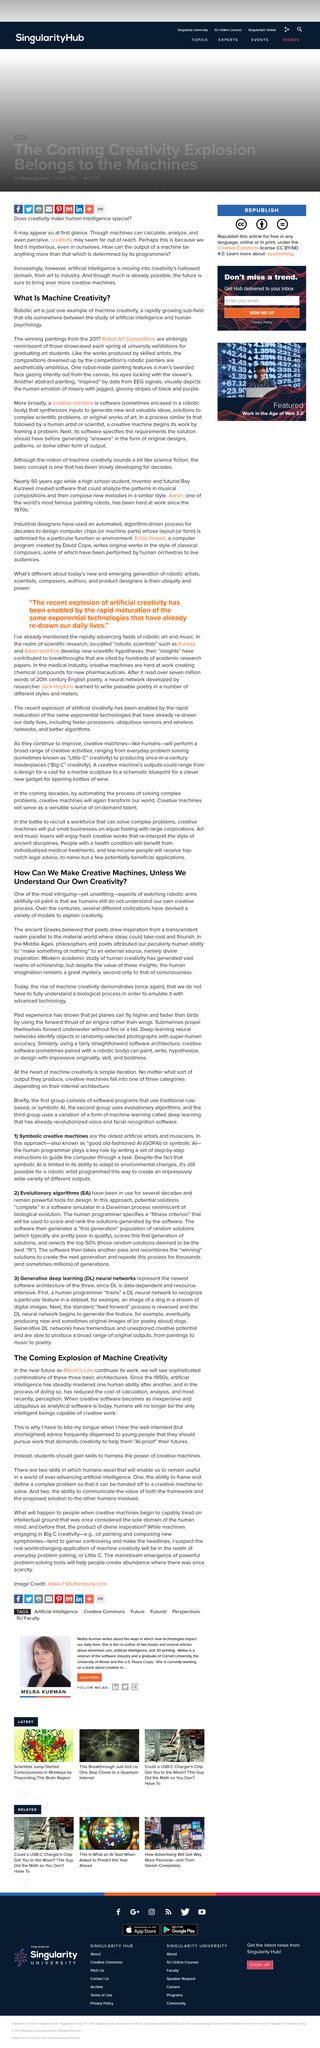Specify some key components in this picture. Philosophers and poets in the Middle Ages attributed the human ability to "make something of nothing" to an external source, which was considered a divine gift. It is necessary for humans to no longer be the only intelligent beings capable of creative work when creative software becomes as inexpensive and ubiquitous as analytical software is today. The study of artificial intelligence and human psychology is what defines machine creativity, which involves the creation of innovative ideas and solutions through the use of advanced algorithms, data analysis, and machine learning techniques. According to the article, machines, in addition to humans, will be capable of creativity and creative work. Machine creativity refers to the use of technology to generate creative works or ideas that would otherwise be difficult or impossible for humans to produce. Examples of machine creativity include robotic art, which is created by computer programs or robots that use algorithms to generate visual or auditory content, and artificial intelligence-powered writing, which involves the use of machine learning models to generate written content. 